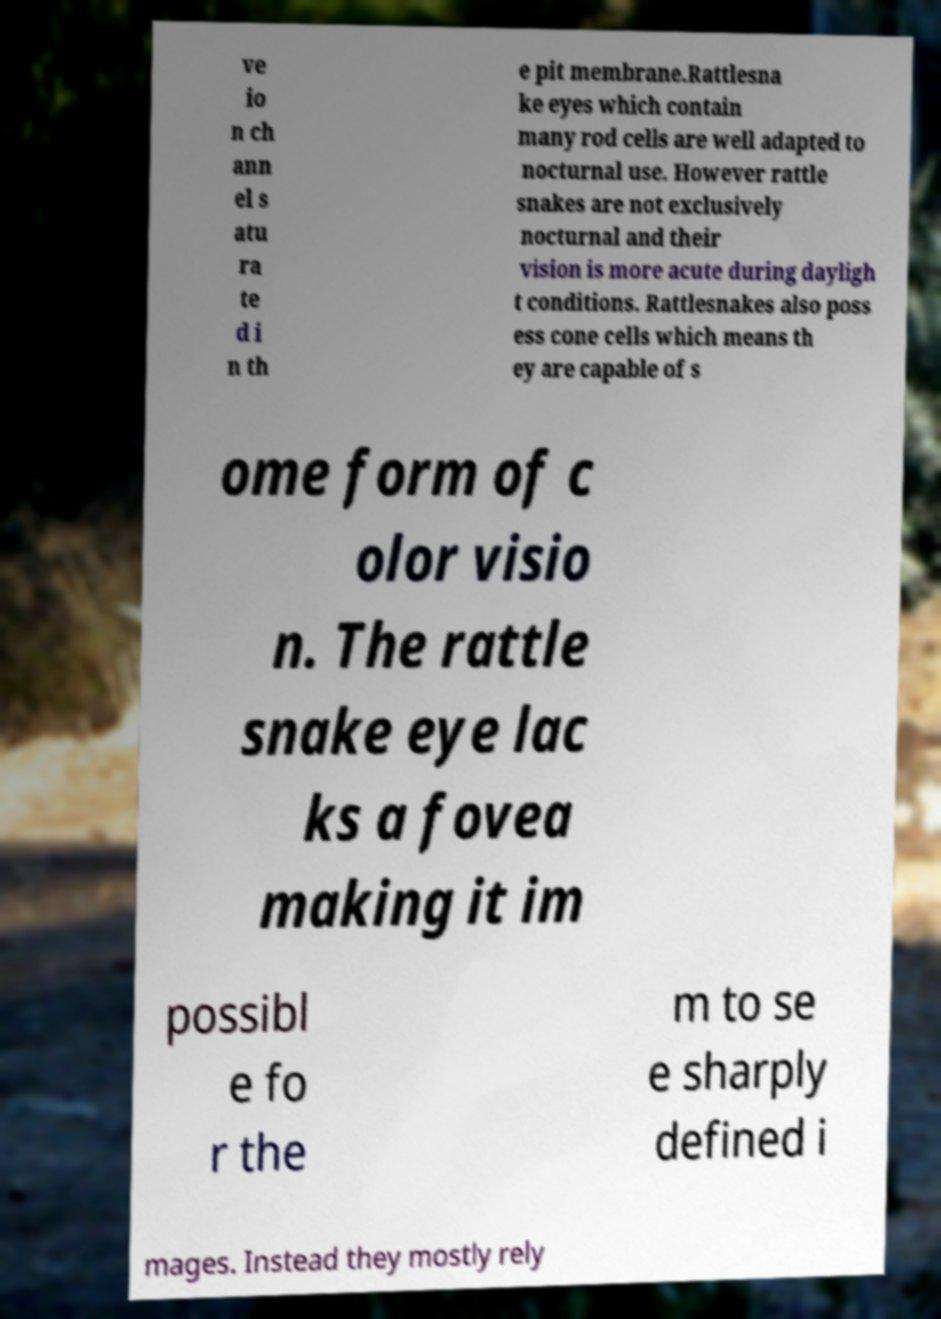Please identify and transcribe the text found in this image. ve io n ch ann el s atu ra te d i n th e pit membrane.Rattlesna ke eyes which contain many rod cells are well adapted to nocturnal use. However rattle snakes are not exclusively nocturnal and their vision is more acute during dayligh t conditions. Rattlesnakes also poss ess cone cells which means th ey are capable of s ome form of c olor visio n. The rattle snake eye lac ks a fovea making it im possibl e fo r the m to se e sharply defined i mages. Instead they mostly rely 